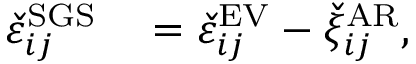Convert formula to latex. <formula><loc_0><loc_0><loc_500><loc_500>\begin{array} { r l } { \check { \varepsilon } _ { i j } ^ { S G S } } & = \check { \varepsilon } _ { i j } ^ { E V } - \check { \xi } _ { i j } ^ { A R } , } \end{array}</formula> 